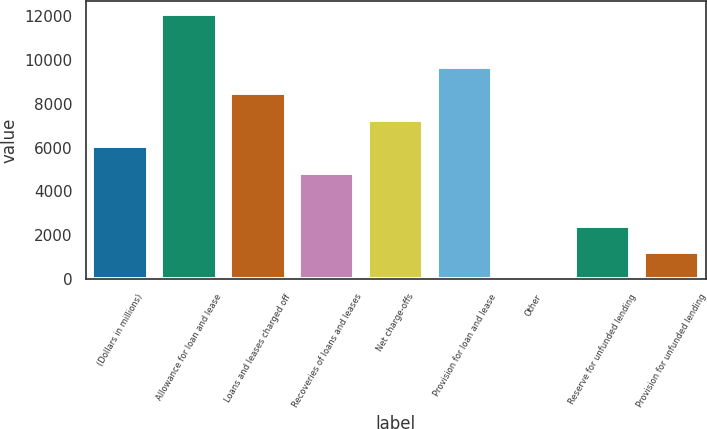<chart> <loc_0><loc_0><loc_500><loc_500><bar_chart><fcel>(Dollars in millions)<fcel>Allowance for loan and lease<fcel>Loans and leases charged off<fcel>Recoveries of loans and leases<fcel>Net charge-offs<fcel>Provision for loan and lease<fcel>Other<fcel>Reserve for unfunded lending<fcel>Provision for unfunded lending<nl><fcel>6064.5<fcel>12106<fcel>8481.1<fcel>4856.2<fcel>7272.8<fcel>9689.4<fcel>23<fcel>2439.6<fcel>1231.3<nl></chart> 